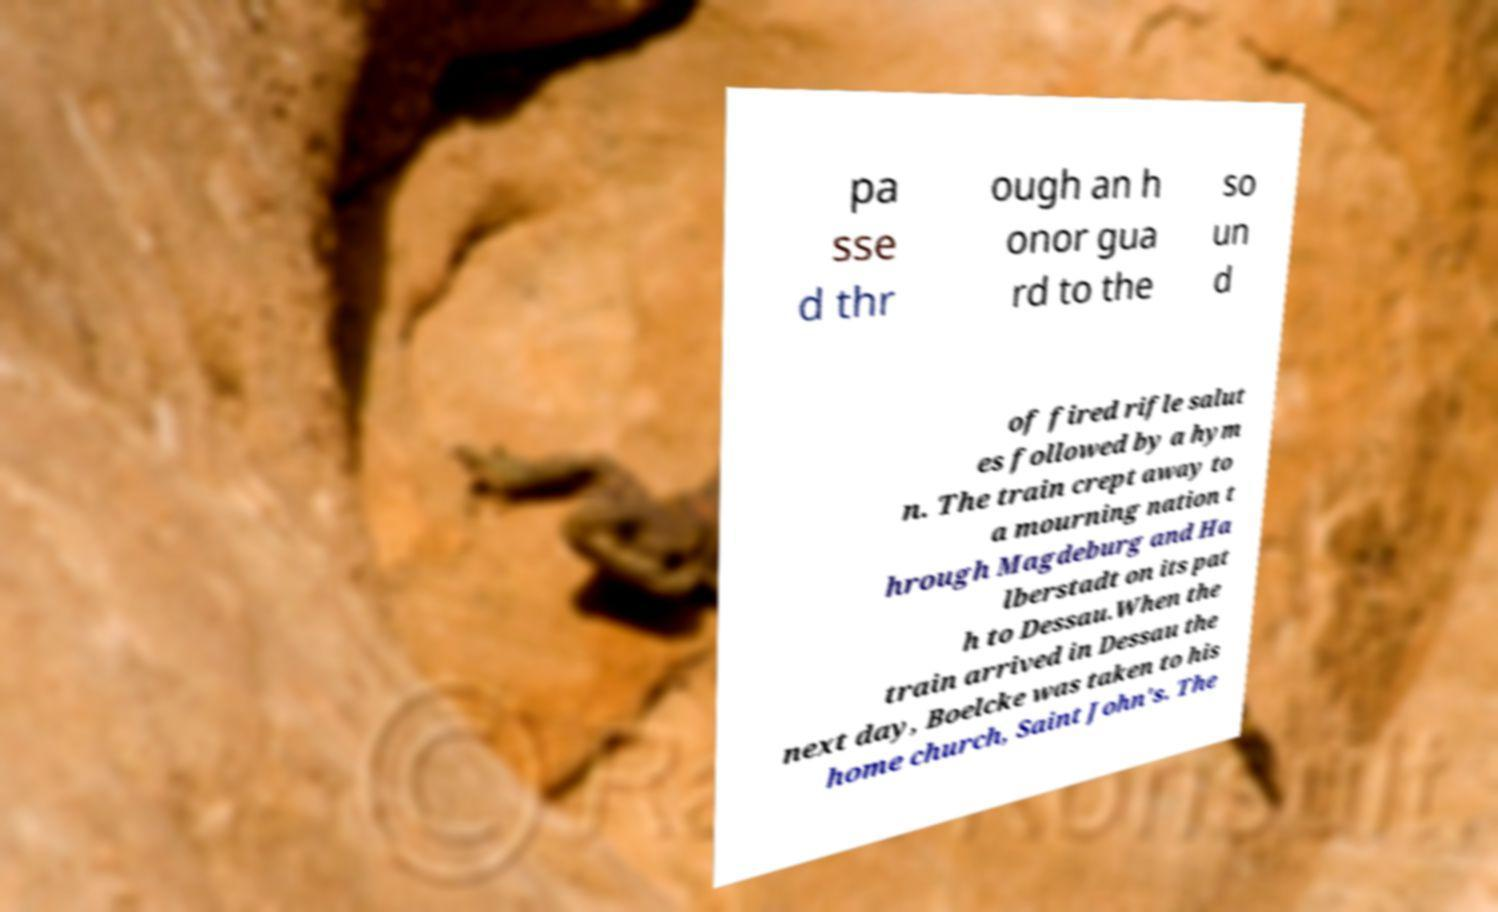Can you read and provide the text displayed in the image?This photo seems to have some interesting text. Can you extract and type it out for me? pa sse d thr ough an h onor gua rd to the so un d of fired rifle salut es followed by a hym n. The train crept away to a mourning nation t hrough Magdeburg and Ha lberstadt on its pat h to Dessau.When the train arrived in Dessau the next day, Boelcke was taken to his home church, Saint John's. The 